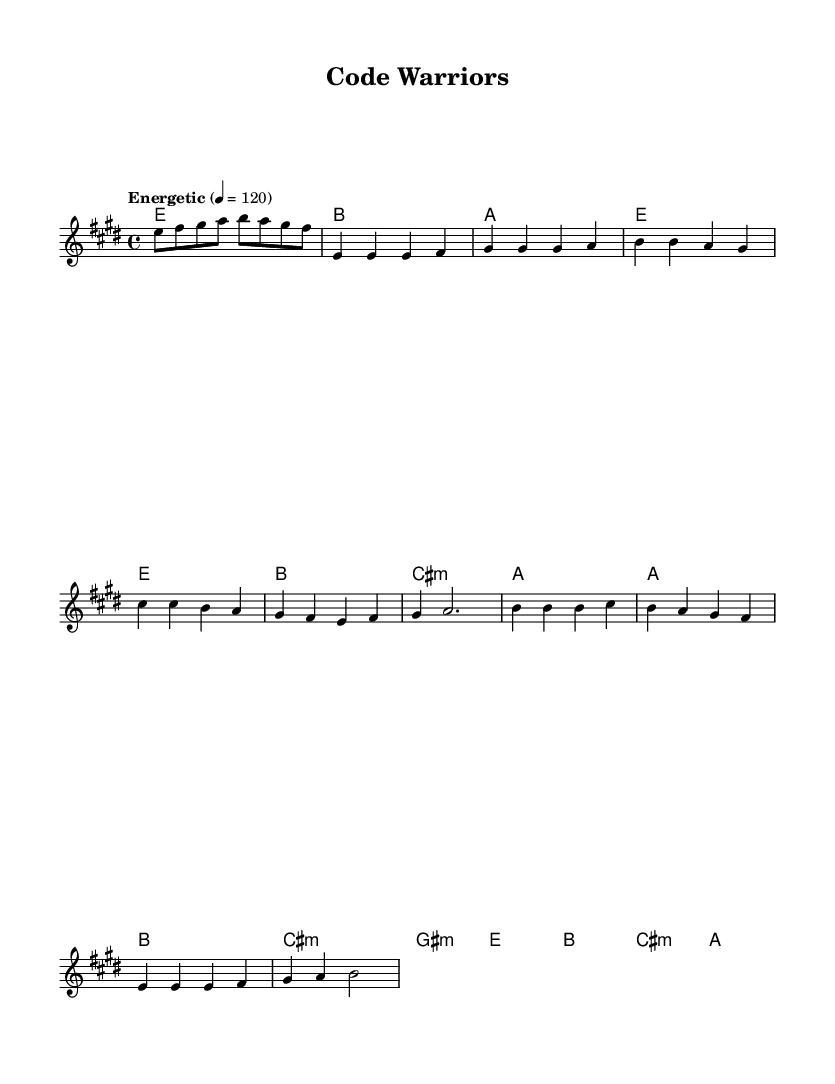What is the key signature of this music? The key signature is E major, which includes four sharps (F#, C#, G#, and D#). This can be confirmed by checking the key signature indicated at the beginning of the score.
Answer: E major What is the time signature of this music? The time signature is 4/4, indicated at the beginning of the score. It reflects that there are four beats in a measure and each quarter note gets one beat.
Answer: 4/4 What is the tempo marking for the piece? The tempo marking indicates "Energetic," and it specifies a tempo of 120 beats per minute (BPM). This is shown in the tempo instruction present in the score.
Answer: Energetic 4 = 120 How many measures are in the chorus? The chorus consists of four measures, which can be counted by analyzing the chord and melody sections labeled as the chorus part of the score.
Answer: 4 What are the lyrics for the pre-chorus? The lyrics for the pre-chorus are "With Blaze as our weapon, we'll conquer ev'ry test." This can be confirmed by checking the lyrics portion of the score underneath the melody.
Answer: With Blaze as our weapon, we'll conquer ev'ry test What is the primary theme of the song? The primary theme of the song is about overcoming challenges, specifically in coding and software development. This can be inferred from the lyrics and overall message of fighting through bugs and errors as a "Code Warrior."
Answer: Overcoming challenges How many chords are used in the pre-chorus? The pre-chorus uses four chords: A, B, C# minor, and G# minor. This is confirmed by looking at the harmonies in the pre-chorus section of the score.
Answer: 4 